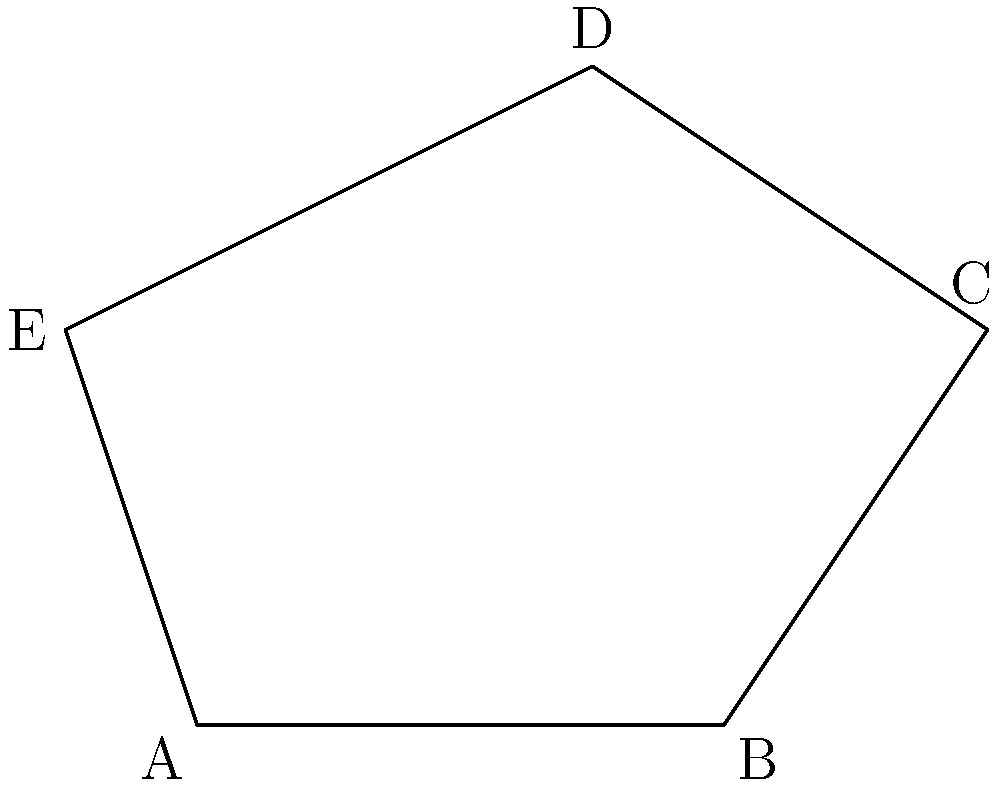In your pentagonal book arrangement on the shelf, each book forms a vertex of a regular pentagon. If the internal angle at vertex A is $108°$, what is the sum of the internal angles of the entire pentagon? To solve this problem, let's follow these steps:

1) First, recall that the sum of the internal angles of any polygon with $n$ sides is given by the formula:

   $S = (n-2) \times 180°$

2) In this case, we have a pentagon, so $n = 5$. Let's substitute this into our formula:

   $S = (5-2) \times 180°$
   $S = 3 \times 180°$
   $S = 540°$

3) We can verify this result by considering that each internal angle of a regular pentagon is $108°$ (as given for vertex A in the question), and there are 5 such angles:

   $5 \times 108° = 540°$

4) This confirms our calculation using the polygon internal angle sum formula.

Therefore, the sum of the internal angles of the pentagon formed by the book arrangement is $540°$.
Answer: $540°$ 